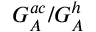<formula> <loc_0><loc_0><loc_500><loc_500>G _ { A } ^ { a c } / G _ { A } ^ { h }</formula> 